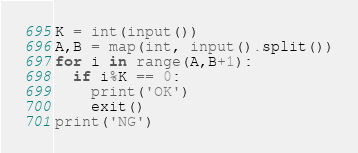Convert code to text. <code><loc_0><loc_0><loc_500><loc_500><_Python_>K = int(input())
A,B = map(int, input().split())
for i in range(A,B+1):
  if i%K == 0:
    print('OK')
    exit()
print('NG')</code> 